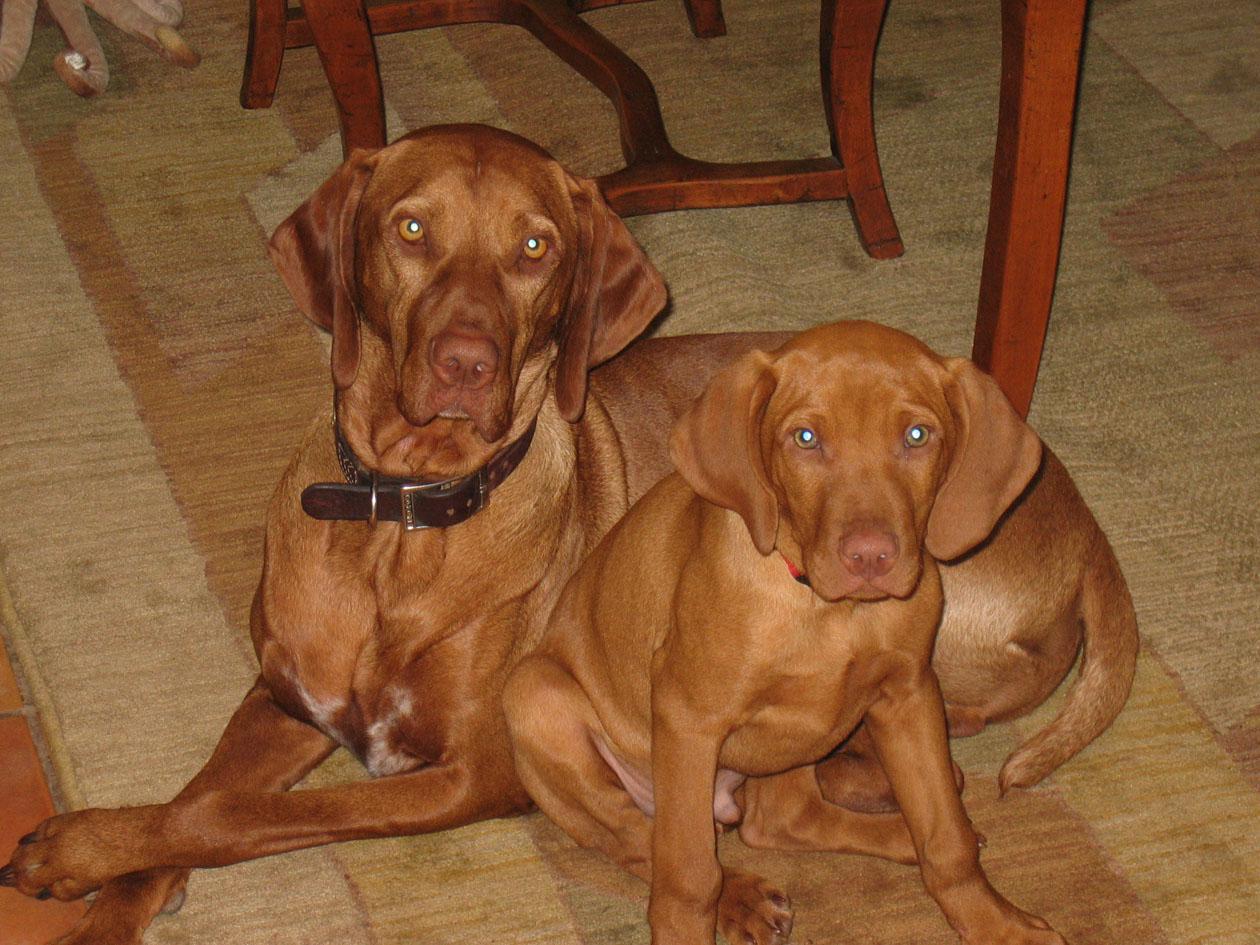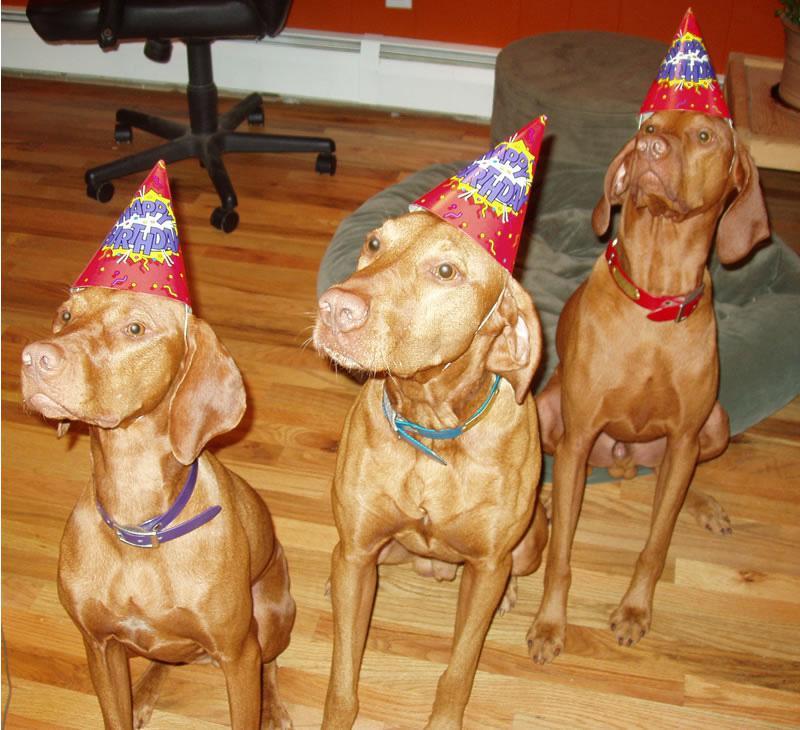The first image is the image on the left, the second image is the image on the right. Evaluate the accuracy of this statement regarding the images: "At least one of the images has a cake in front of the dog.". Is it true? Answer yes or no. No. 